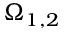Convert formula to latex. <formula><loc_0><loc_0><loc_500><loc_500>\Omega _ { 1 , 2 }</formula> 